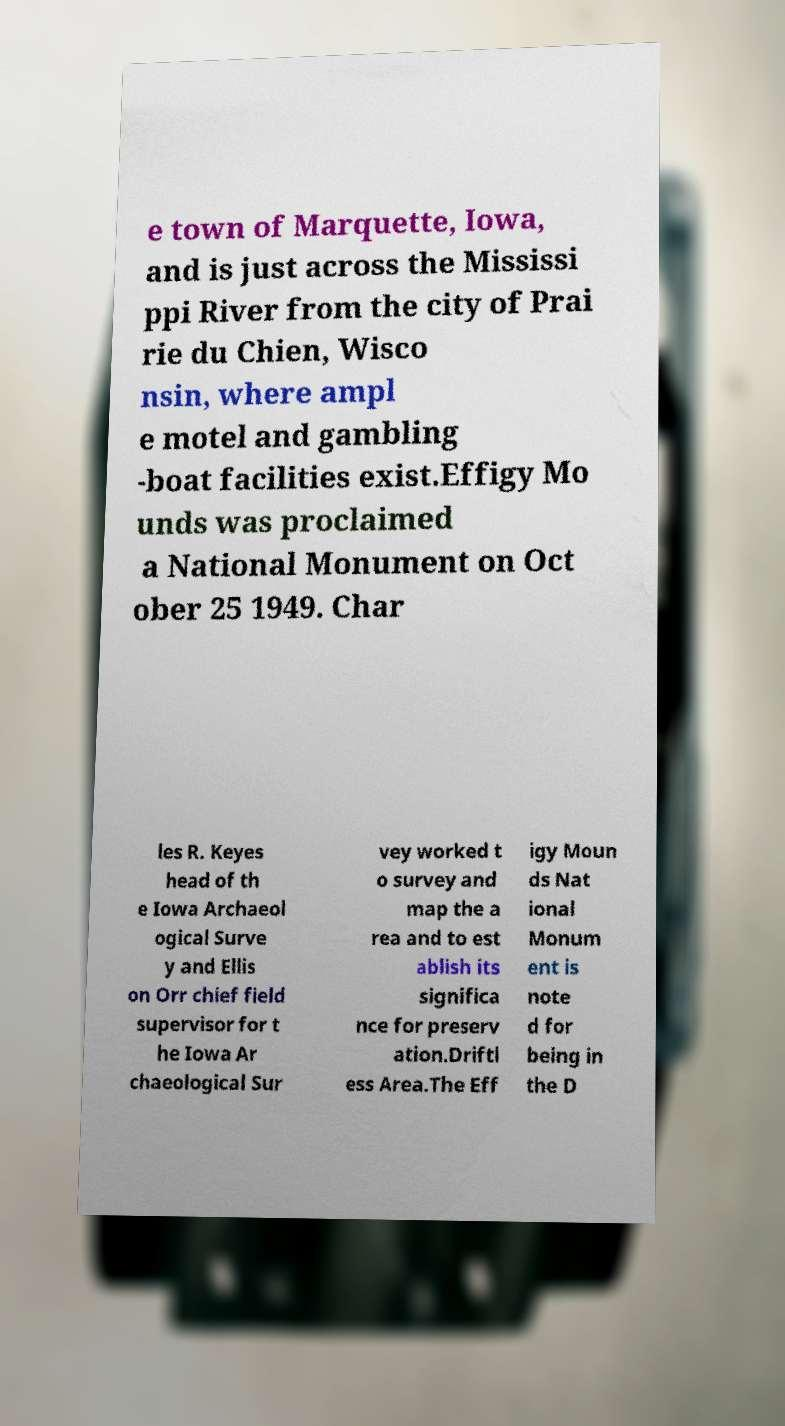Please identify and transcribe the text found in this image. e town of Marquette, Iowa, and is just across the Mississi ppi River from the city of Prai rie du Chien, Wisco nsin, where ampl e motel and gambling -boat facilities exist.Effigy Mo unds was proclaimed a National Monument on Oct ober 25 1949. Char les R. Keyes head of th e Iowa Archaeol ogical Surve y and Ellis on Orr chief field supervisor for t he Iowa Ar chaeological Sur vey worked t o survey and map the a rea and to est ablish its significa nce for preserv ation.Driftl ess Area.The Eff igy Moun ds Nat ional Monum ent is note d for being in the D 